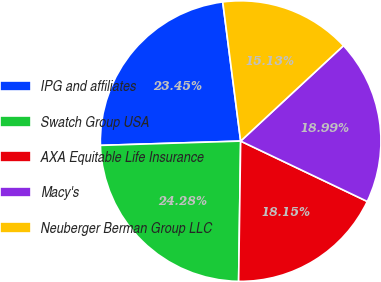Convert chart to OTSL. <chart><loc_0><loc_0><loc_500><loc_500><pie_chart><fcel>IPG and affiliates<fcel>Swatch Group USA<fcel>AXA Equitable Life Insurance<fcel>Macy's<fcel>Neuberger Berman Group LLC<nl><fcel>23.45%<fcel>24.28%<fcel>18.15%<fcel>18.99%<fcel>15.13%<nl></chart> 